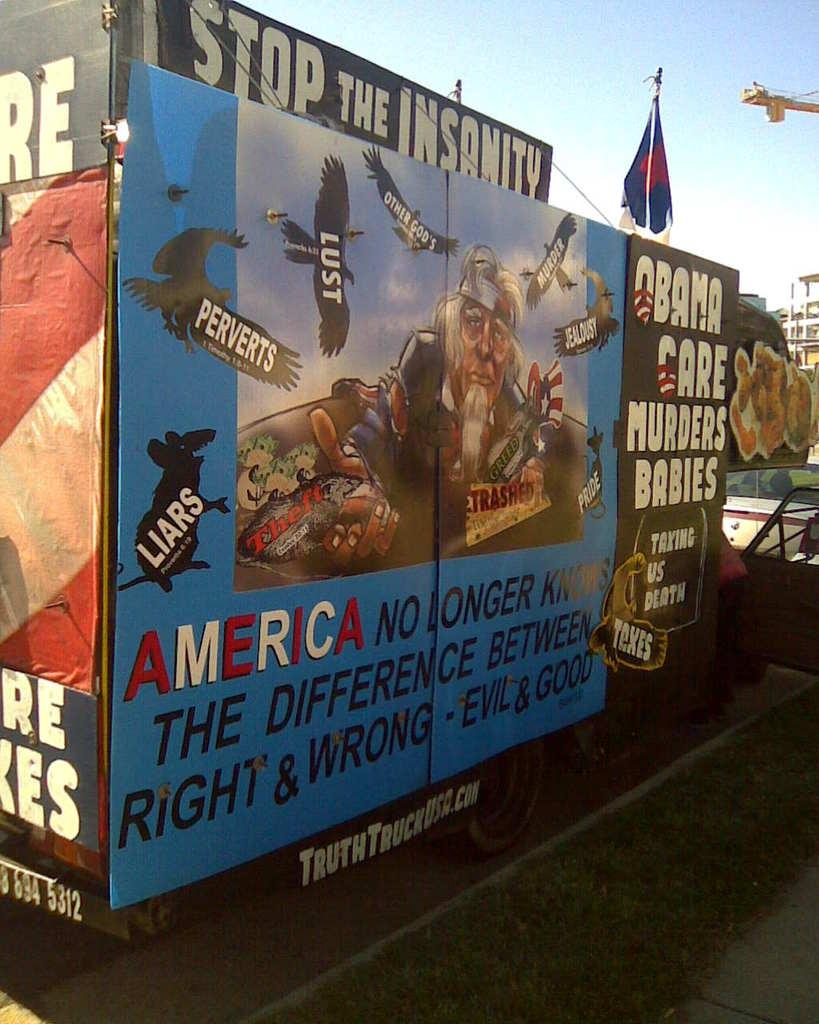<image>
Provide a brief description of the given image. An outdoor sign that says "Stop The Insanity Obama Care Murders Babies" 